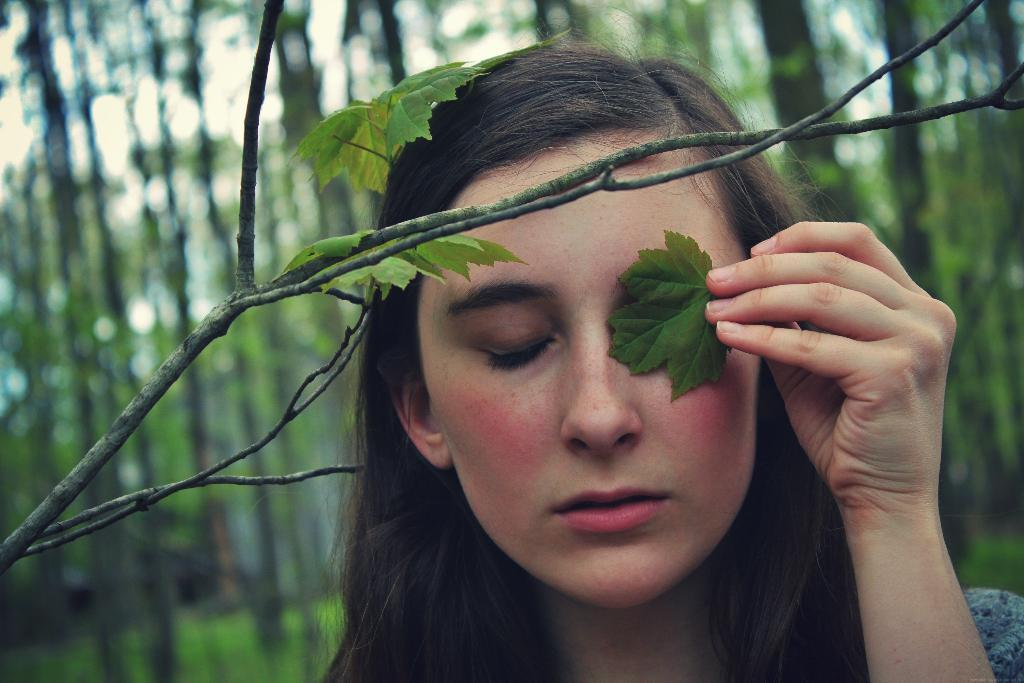Who is the main subject in the image? There is a woman in the image. What is the woman doing with the leaf? The woman is holding a leaf near her eye. What else can be seen in the image besides the woman? There is a plant in the image. What is the condition of the background in the image? The background of the image is blurred. What type of vegetation is visible in the background? Trees are visible in the background of the image. How many brothers does the woman have, and are they present in the image? There is no information about the woman's brothers in the image, nor are they visible. What type of ink is used to draw the plant in the image? The image is not a drawing, and therefore there is no ink used. 